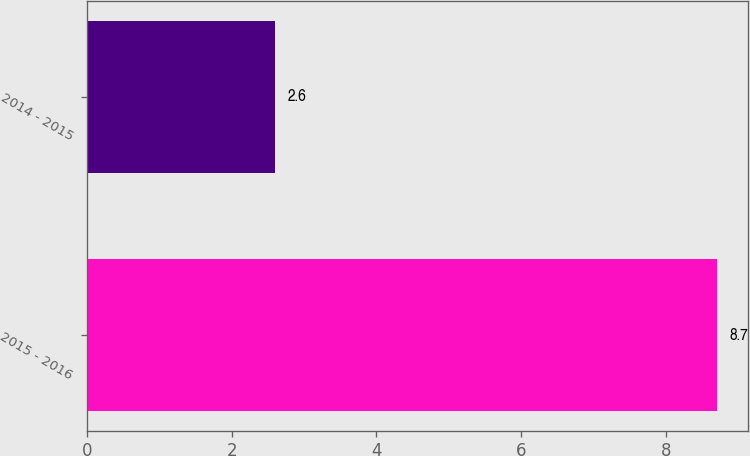<chart> <loc_0><loc_0><loc_500><loc_500><bar_chart><fcel>2015 - 2016<fcel>2014 - 2015<nl><fcel>8.7<fcel>2.6<nl></chart> 